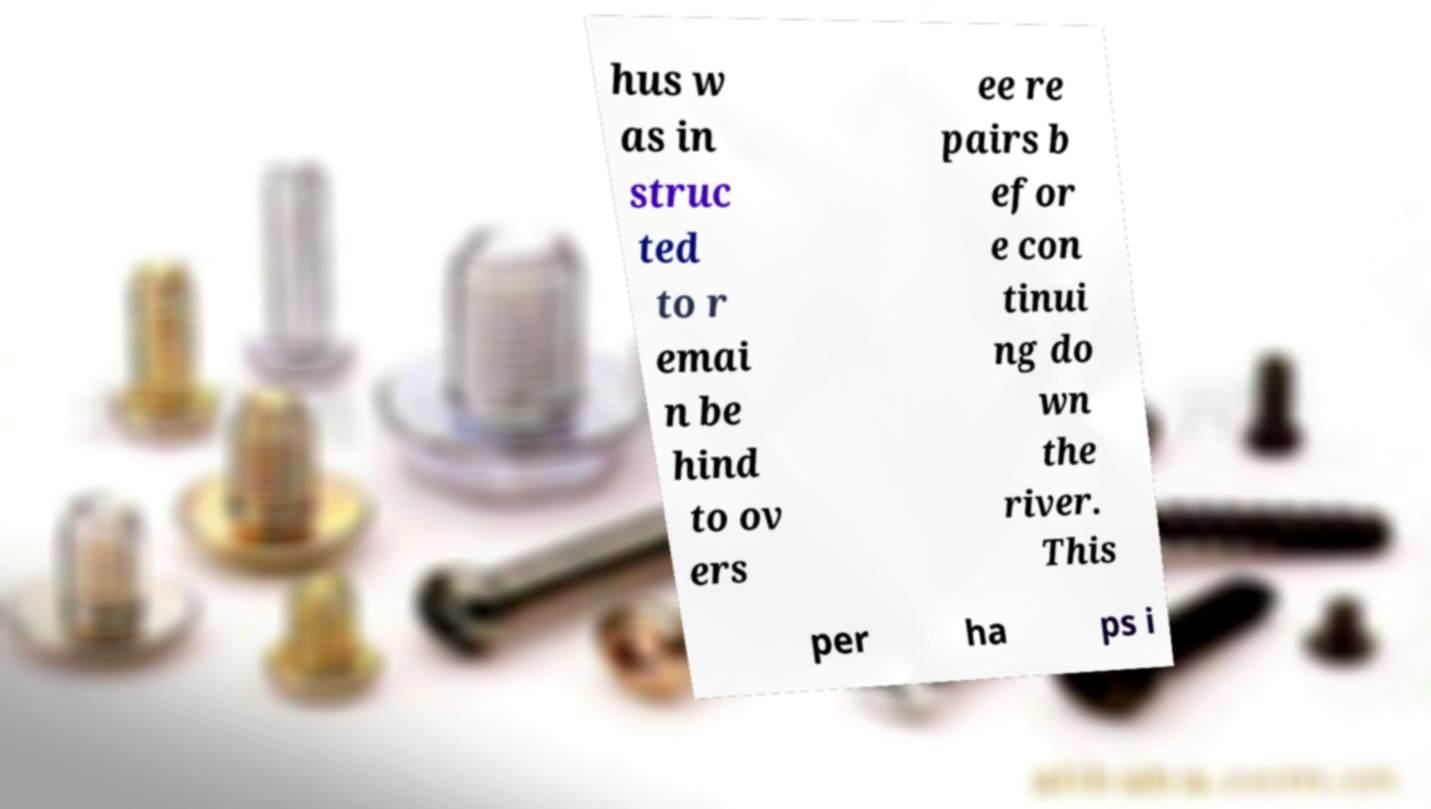I need the written content from this picture converted into text. Can you do that? hus w as in struc ted to r emai n be hind to ov ers ee re pairs b efor e con tinui ng do wn the river. This per ha ps i 